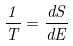Convert formula to latex. <formula><loc_0><loc_0><loc_500><loc_500>\frac { 1 } { T } = \frac { d S } { d E }</formula> 